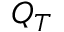<formula> <loc_0><loc_0><loc_500><loc_500>Q _ { T }</formula> 